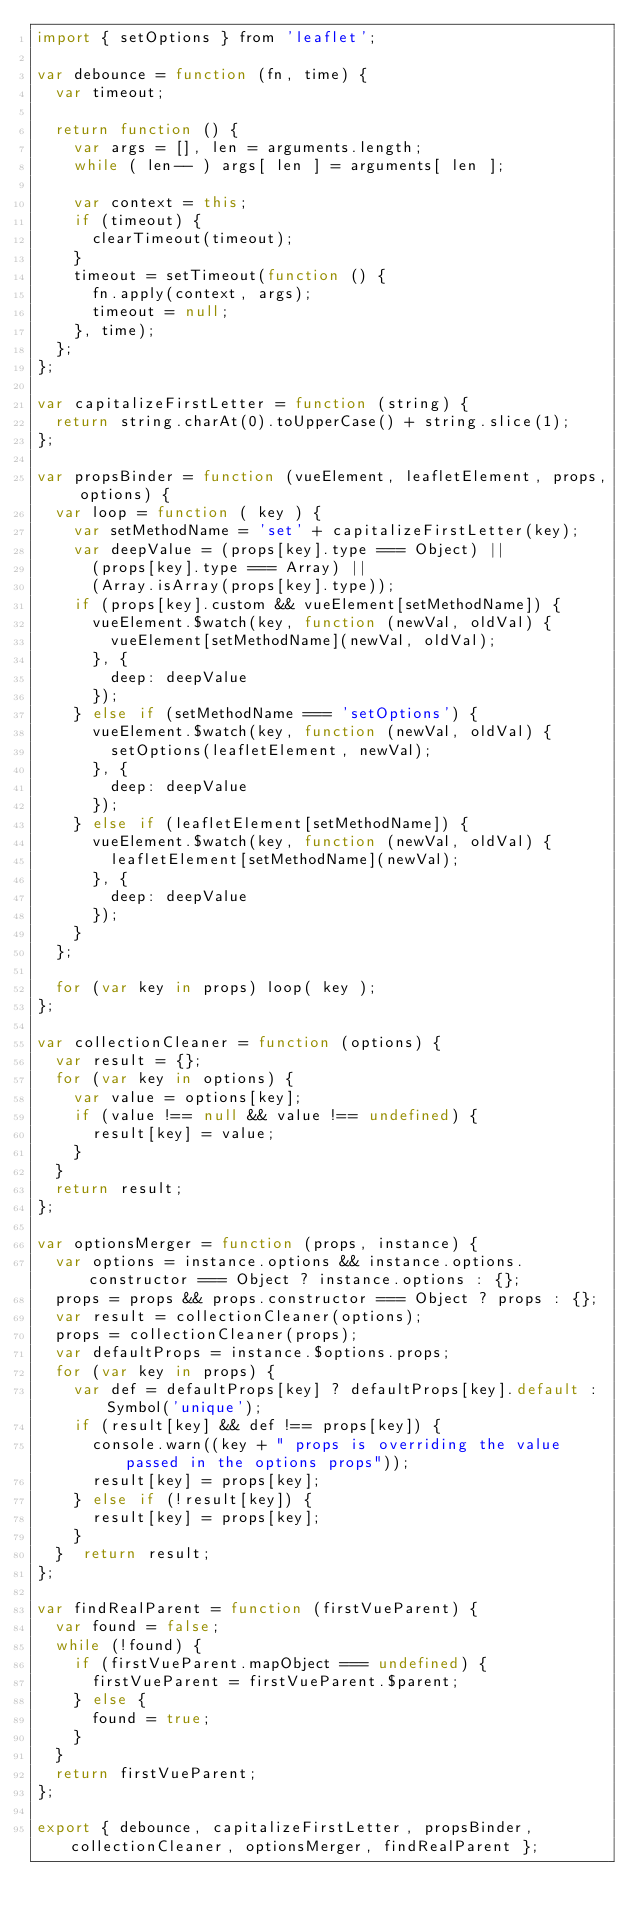Convert code to text. <code><loc_0><loc_0><loc_500><loc_500><_JavaScript_>import { setOptions } from 'leaflet';

var debounce = function (fn, time) {
  var timeout;

  return function () {
    var args = [], len = arguments.length;
    while ( len-- ) args[ len ] = arguments[ len ];

    var context = this;
    if (timeout) {
      clearTimeout(timeout);
    }
    timeout = setTimeout(function () {
      fn.apply(context, args);
      timeout = null;
    }, time);
  };
};

var capitalizeFirstLetter = function (string) {
  return string.charAt(0).toUpperCase() + string.slice(1);
};

var propsBinder = function (vueElement, leafletElement, props, options) {
  var loop = function ( key ) {
    var setMethodName = 'set' + capitalizeFirstLetter(key);
    var deepValue = (props[key].type === Object) ||
      (props[key].type === Array) ||
      (Array.isArray(props[key].type));
    if (props[key].custom && vueElement[setMethodName]) {
      vueElement.$watch(key, function (newVal, oldVal) {
        vueElement[setMethodName](newVal, oldVal);
      }, {
        deep: deepValue
      });
    } else if (setMethodName === 'setOptions') {
      vueElement.$watch(key, function (newVal, oldVal) {
        setOptions(leafletElement, newVal);
      }, {
        deep: deepValue
      });
    } else if (leafletElement[setMethodName]) {
      vueElement.$watch(key, function (newVal, oldVal) {
        leafletElement[setMethodName](newVal);
      }, {
        deep: deepValue
      });
    }
  };

  for (var key in props) loop( key );
};

var collectionCleaner = function (options) {
  var result = {};
  for (var key in options) {
    var value = options[key];
    if (value !== null && value !== undefined) {
      result[key] = value;
    }
  }
  return result;
};

var optionsMerger = function (props, instance) {
  var options = instance.options && instance.options.constructor === Object ? instance.options : {};
  props = props && props.constructor === Object ? props : {};
  var result = collectionCleaner(options);
  props = collectionCleaner(props);
  var defaultProps = instance.$options.props;
  for (var key in props) {
    var def = defaultProps[key] ? defaultProps[key].default : Symbol('unique');
    if (result[key] && def !== props[key]) {
      console.warn((key + " props is overriding the value passed in the options props"));
      result[key] = props[key];
    } else if (!result[key]) {
      result[key] = props[key];
    }
  }  return result;
};

var findRealParent = function (firstVueParent) {
  var found = false;
  while (!found) {
    if (firstVueParent.mapObject === undefined) {
      firstVueParent = firstVueParent.$parent;
    } else {
      found = true;
    }
  }
  return firstVueParent;
};

export { debounce, capitalizeFirstLetter, propsBinder, collectionCleaner, optionsMerger, findRealParent };
</code> 